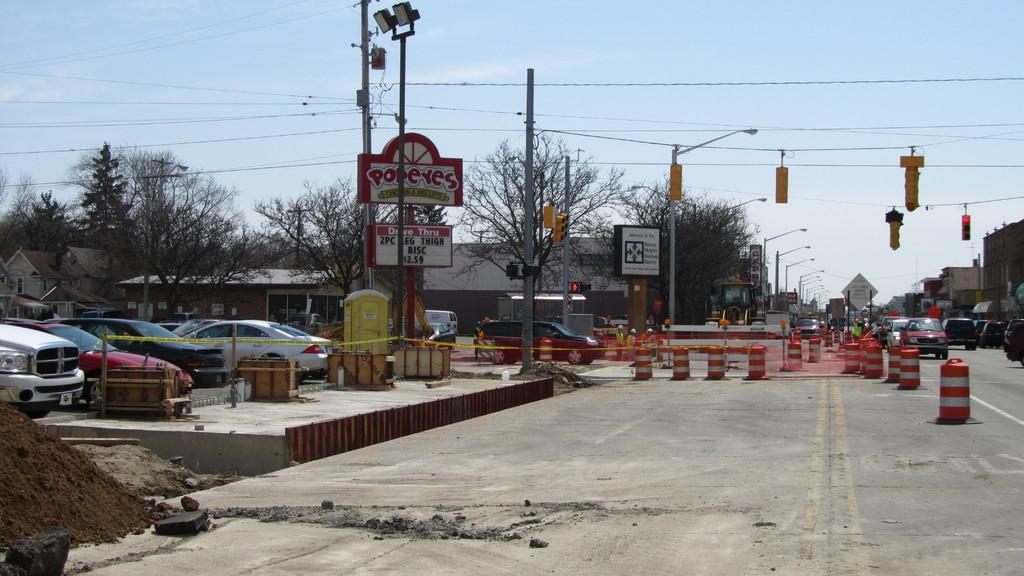<image>
Create a compact narrative representing the image presented. The entire right side of a main road, where a Popeye's restaurant is, has construction barrels surrounding it and parts of the road torn up. 